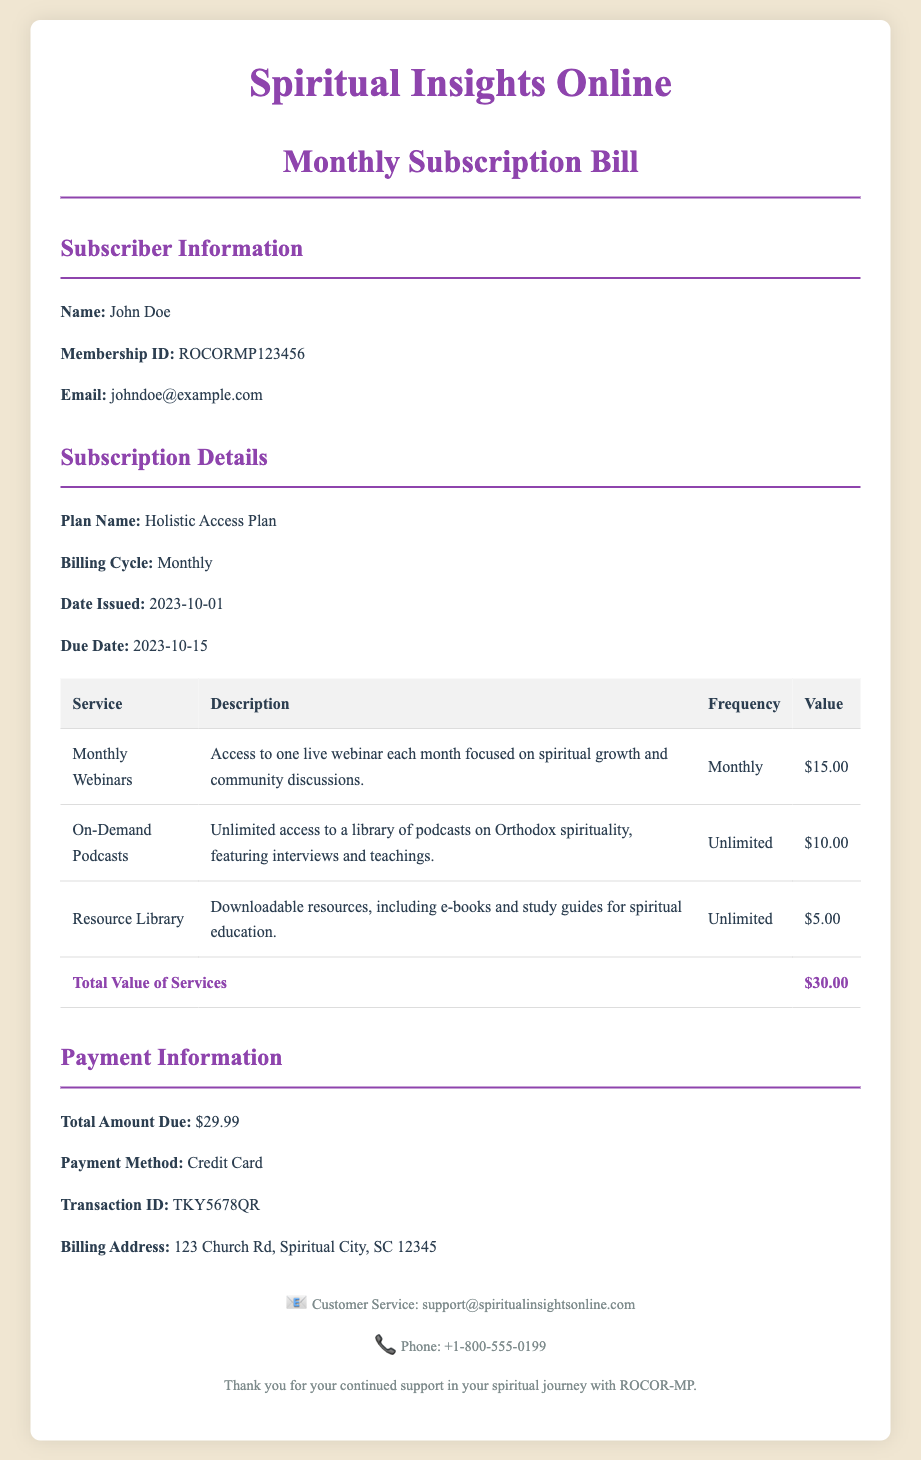What is the subscriber's name? The subscriber's name is stated in the document under Subscriber Information.
Answer: John Doe What is the membership ID? The membership ID can be found in the Subscriber Information section of the document.
Answer: ROCORMP123456 What is the plan name? The plan name is specified in the Subscription Details section of the document.
Answer: Holistic Access Plan What is the total amount due? The total amount due is listed in the Payment Information section.
Answer: $29.99 When is the due date for payment? The due date is provided in the Subscription Details section of the document.
Answer: 2023-10-15 How many live webinars are included monthly? The number of live webinars is mentioned in the description of the Monthly Webinars service.
Answer: One What is the value of on-demand podcasts? The value of on-demand podcasts is shown in the table under Subscription Details.
Answer: $10.00 What payment method is used? The payment method is stated in the Payment Information section.
Answer: Credit Card What is the billing address? The billing address is available in the Payment Information section.
Answer: 123 Church Rd, Spiritual City, SC 12345 